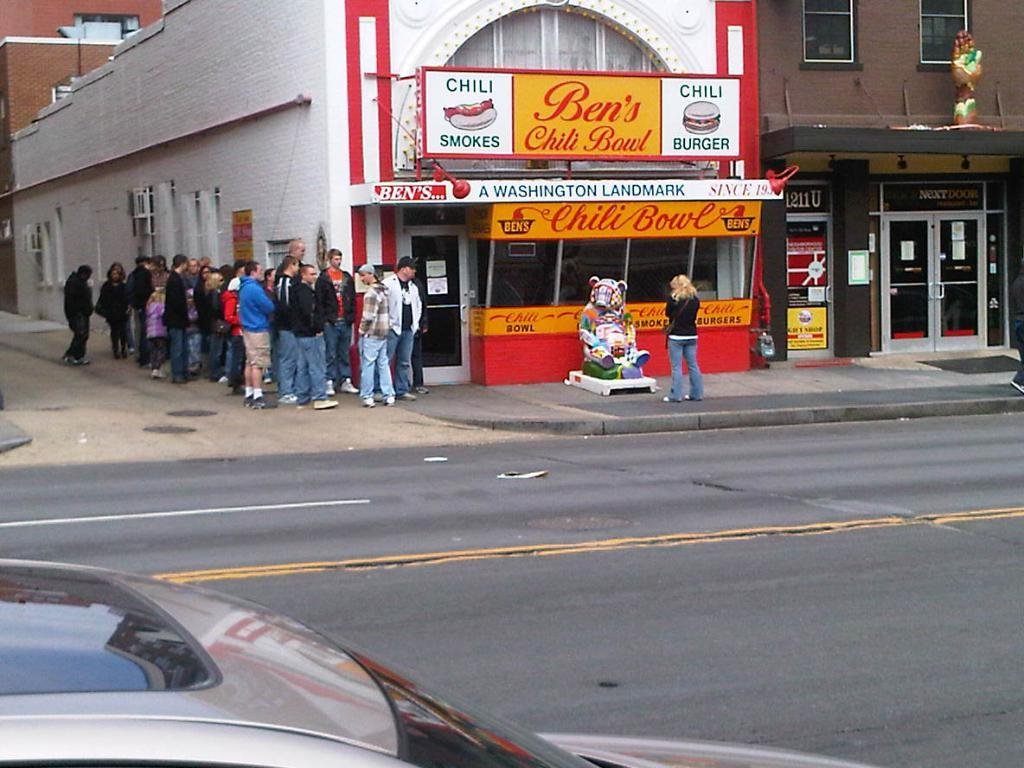Provide a one-sentence caption for the provided image. A line of people wait outside of Ben's Chili Stand. 